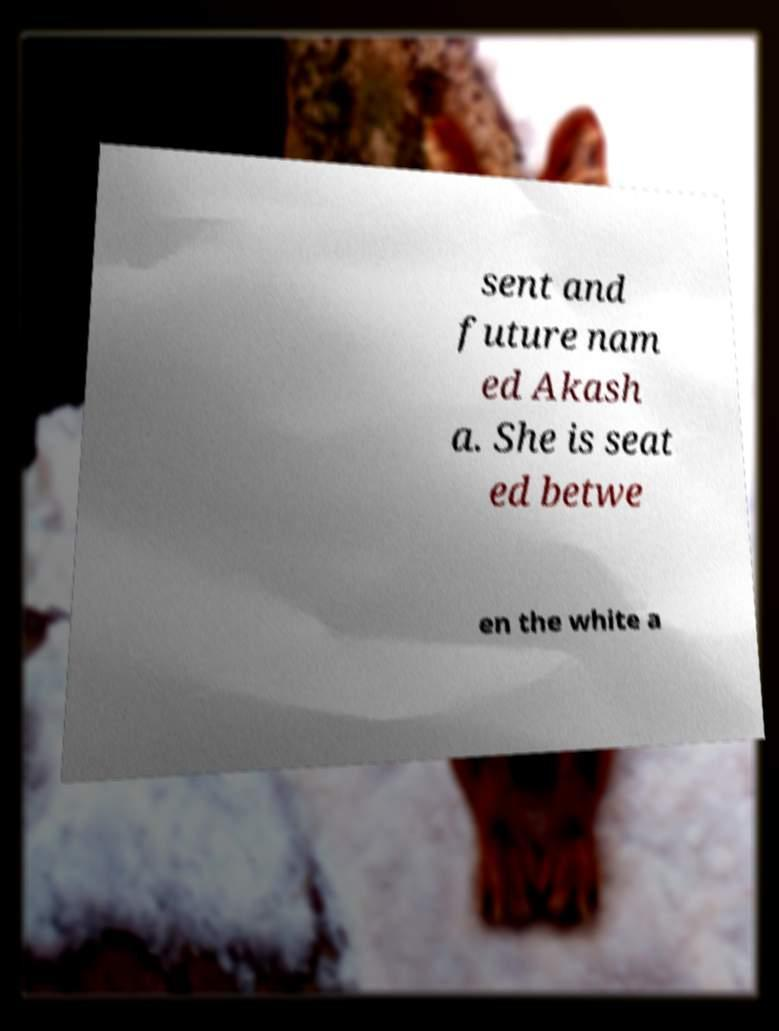What messages or text are displayed in this image? I need them in a readable, typed format. sent and future nam ed Akash a. She is seat ed betwe en the white a 